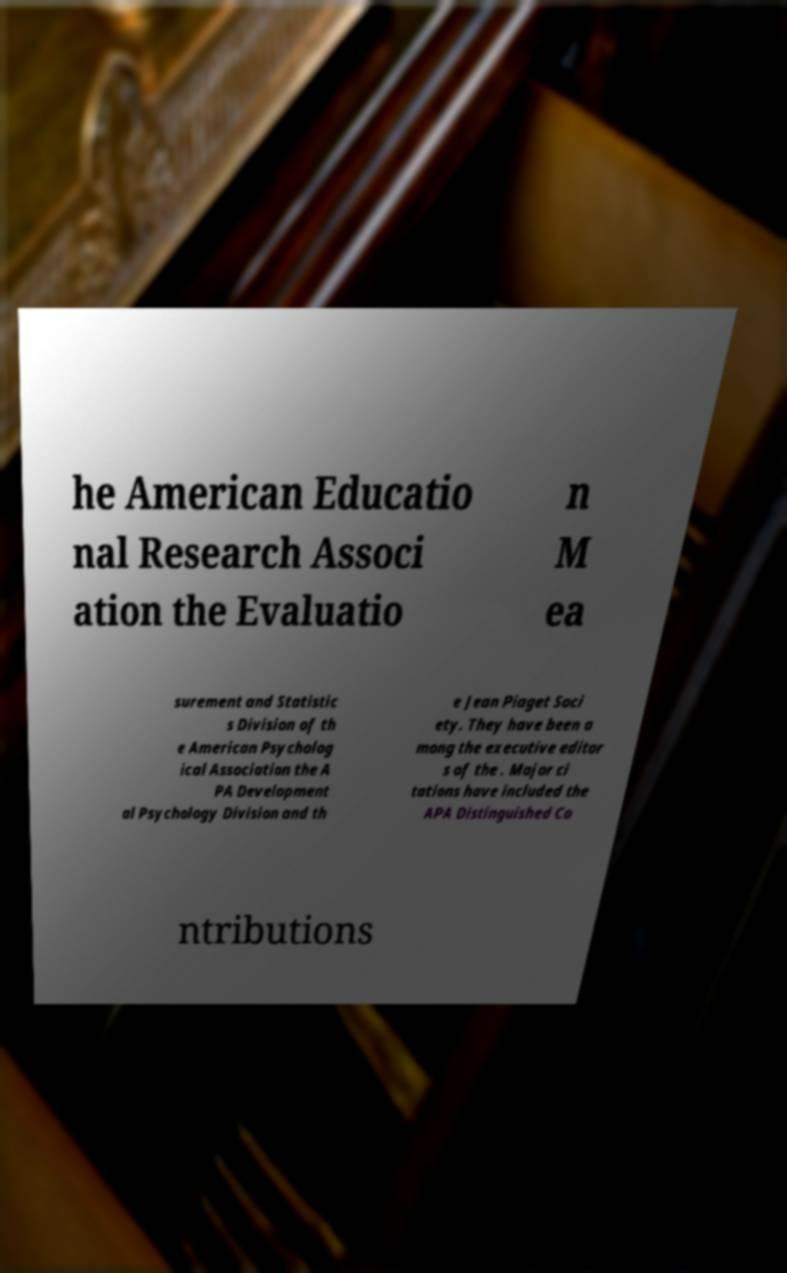Could you extract and type out the text from this image? he American Educatio nal Research Associ ation the Evaluatio n M ea surement and Statistic s Division of th e American Psycholog ical Association the A PA Development al Psychology Division and th e Jean Piaget Soci ety. They have been a mong the executive editor s of the . Major ci tations have included the APA Distinguished Co ntributions 